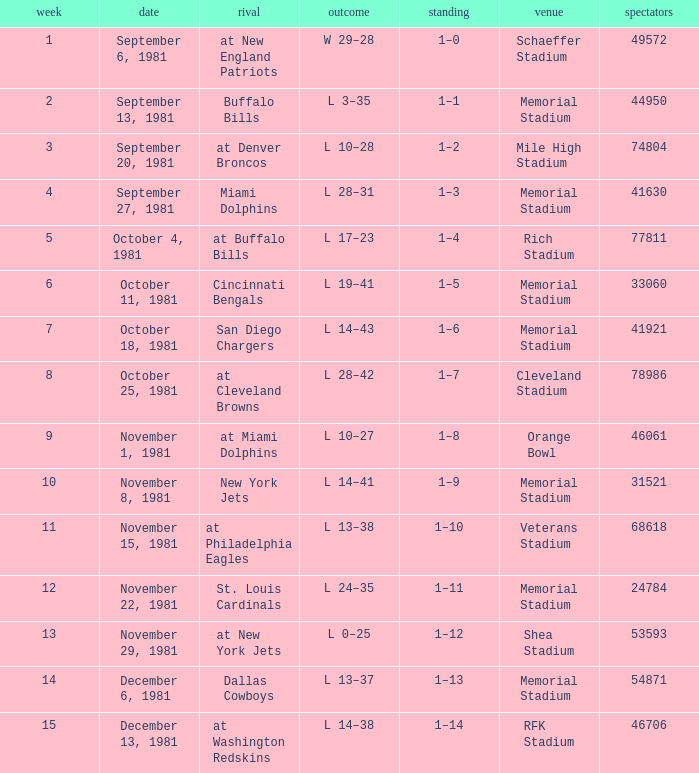When it is October 25, 1981 who is the opponent? At cleveland browns. 